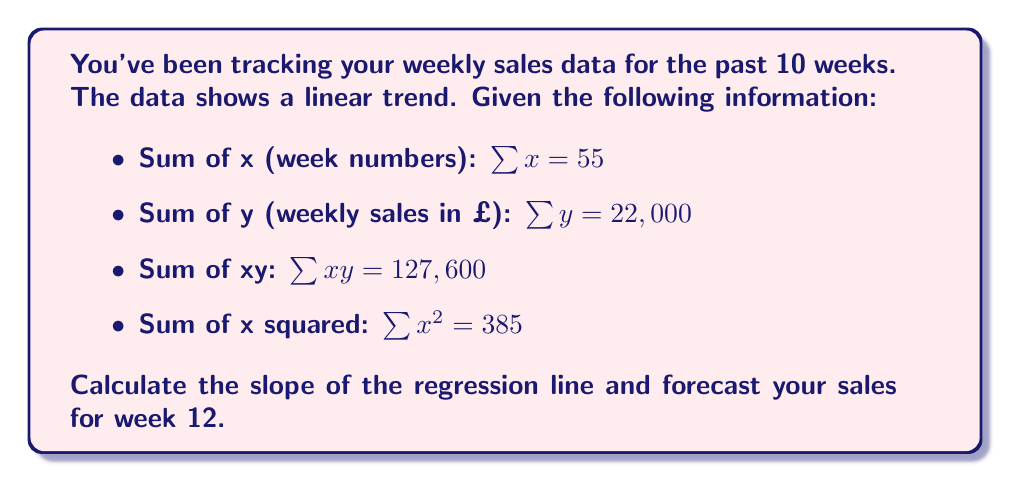Solve this math problem. To solve this problem, we'll use simple linear regression. The formula for the slope (b) of the regression line is:

$$b = \frac{n\sum xy - \sum x \sum y}{n\sum x^2 - (\sum x)^2}$$

Where n is the number of data points (10 in this case).

Step 1: Calculate the slope (b)
$$b = \frac{10(127,600) - 55(22,000)}{10(385) - 55^2}$$
$$b = \frac{1,276,000 - 1,210,000}{3,850 - 3,025}$$
$$b = \frac{66,000}{825} = 80$$

The slope is 80, meaning sales increase by £80 each week on average.

Step 2: Calculate the y-intercept (a)
Use the formula: $a = \bar{y} - b\bar{x}$
Where $\bar{y} = \frac{\sum y}{n}$ and $\bar{x} = \frac{\sum x}{n}$

$\bar{y} = \frac{22,000}{10} = 2,200$
$\bar{x} = \frac{55}{10} = 5.5$

$a = 2,200 - 80(5.5) = 1,760$

Step 3: Write the regression equation
$y = 1,760 + 80x$

Step 4: Forecast sales for week 12
Substitute x = 12 into the equation:
$y = 1,760 + 80(12) = 1,760 + 960 = 2,720$

Therefore, the forecast sales for week 12 are £2,720.
Answer: £2,720 